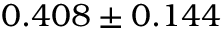Convert formula to latex. <formula><loc_0><loc_0><loc_500><loc_500>0 . 4 0 8 \pm 0 . 1 4 4</formula> 